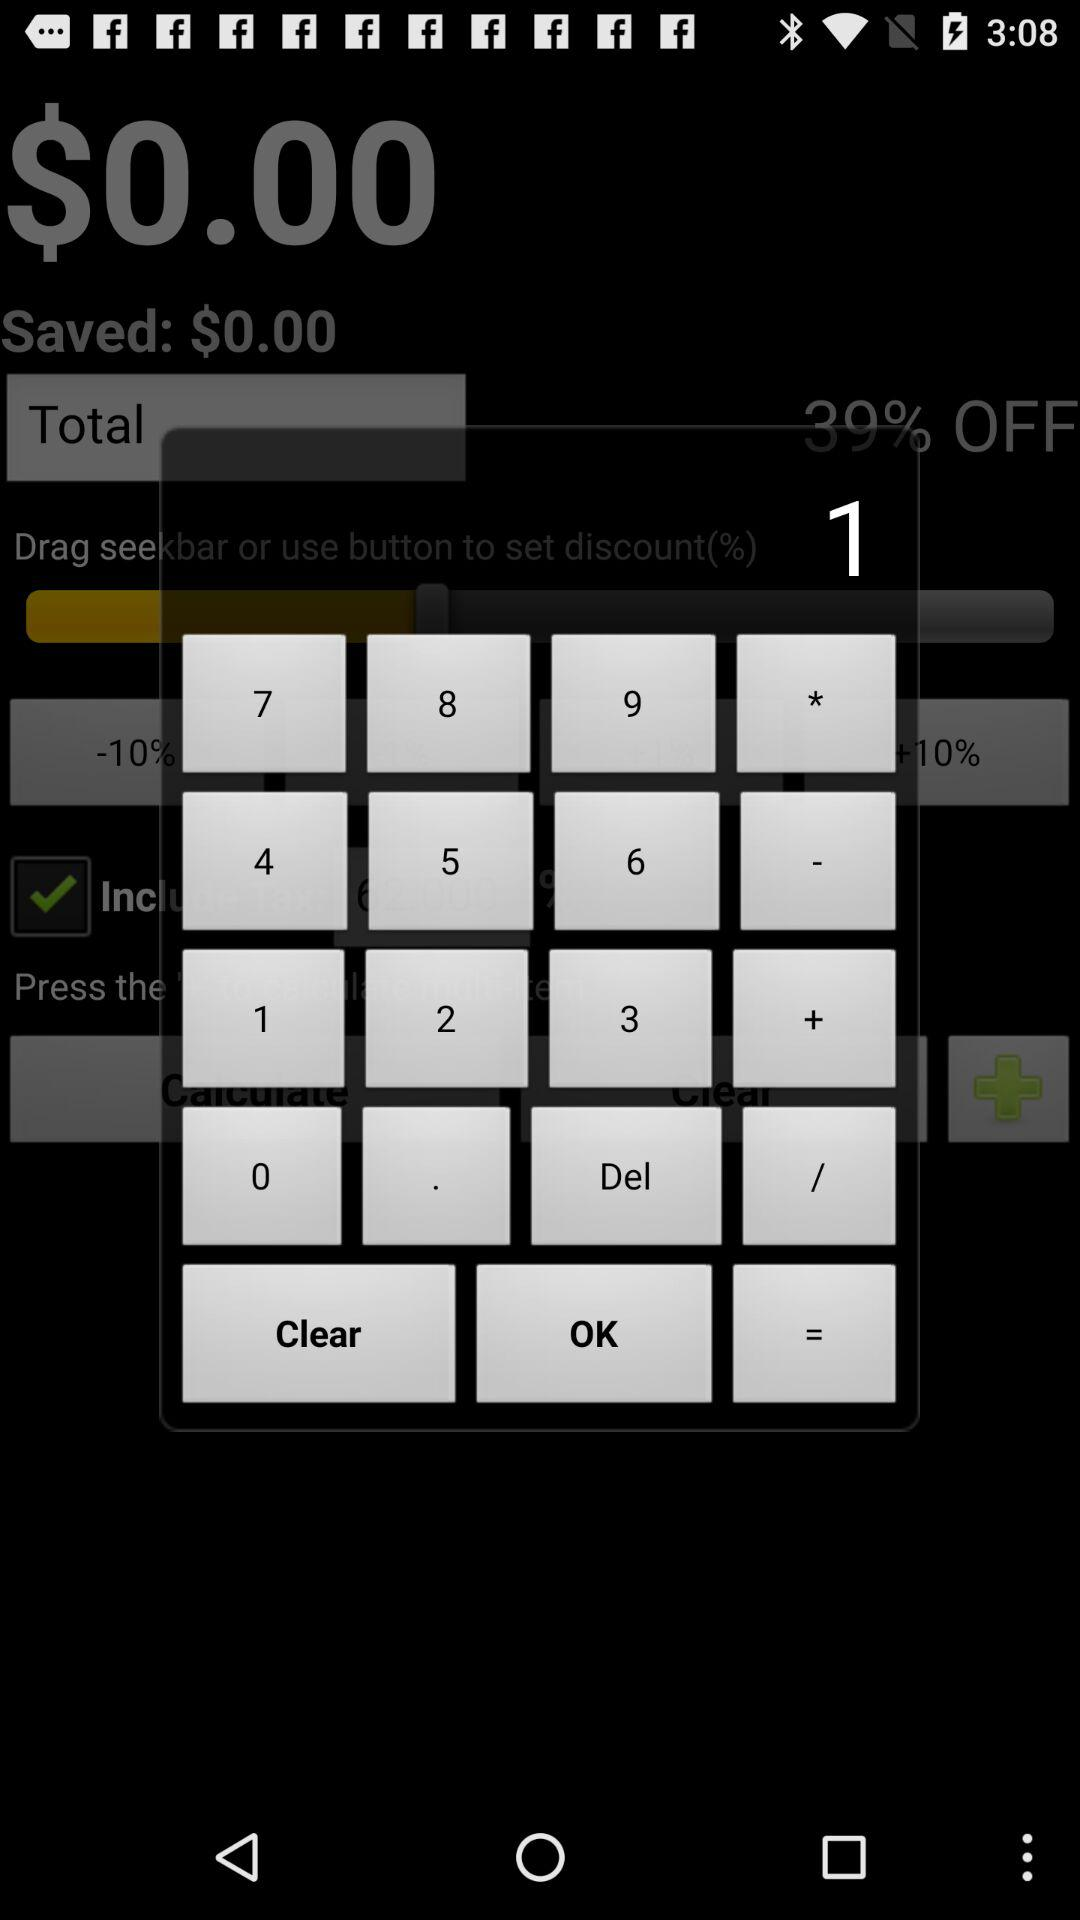What is the current discount percentage?
Answer the question using a single word or phrase. 39% 